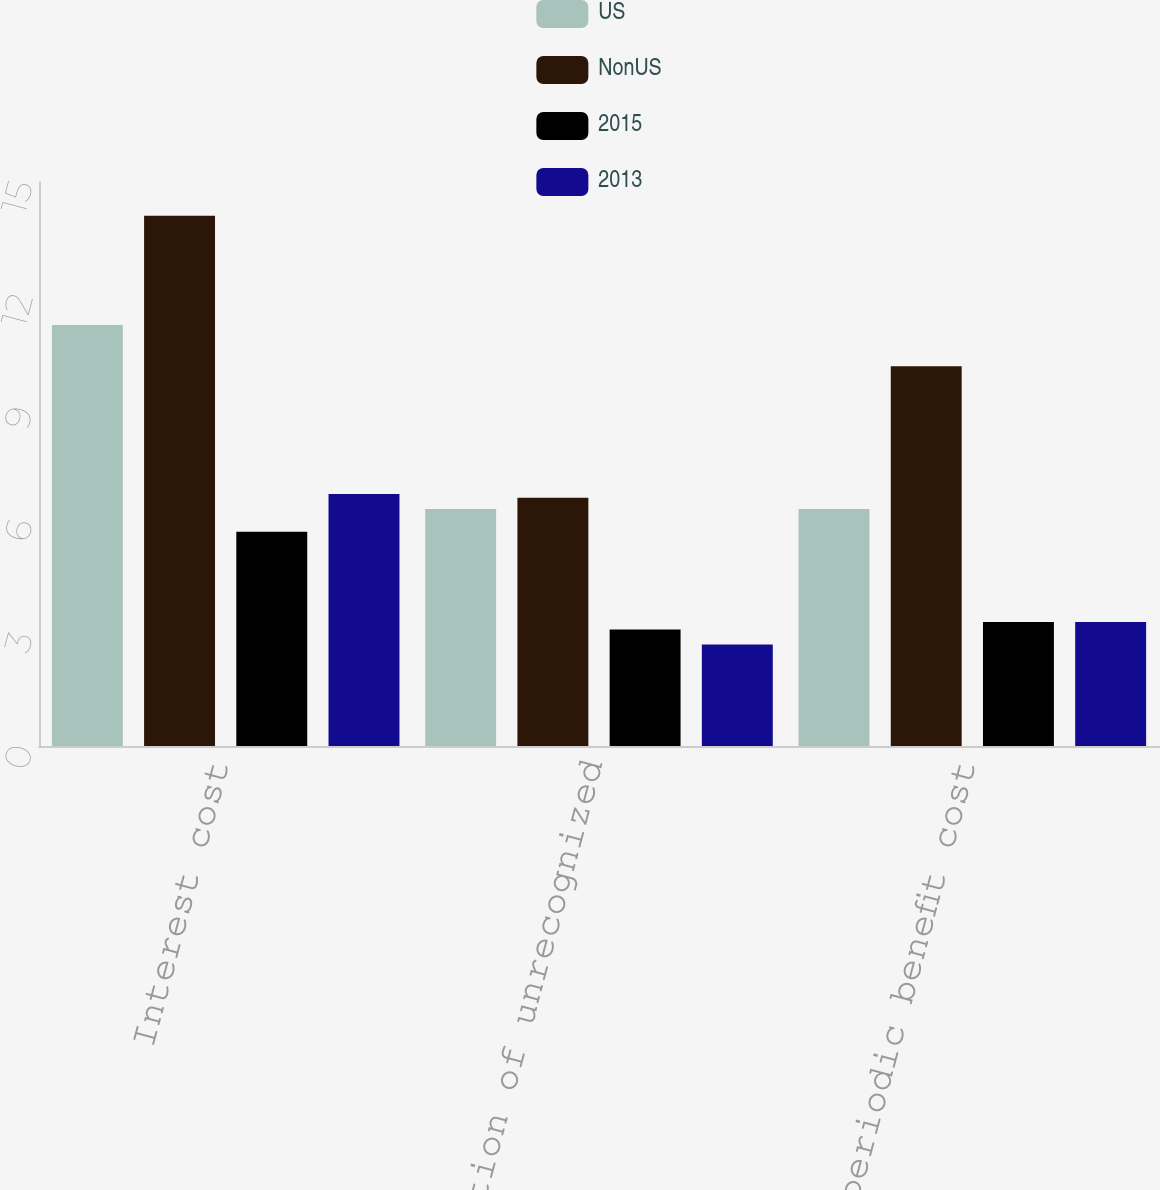Convert chart to OTSL. <chart><loc_0><loc_0><loc_500><loc_500><stacked_bar_chart><ecel><fcel>Interest cost<fcel>Amortization of unrecognized<fcel>Net periodic benefit cost<nl><fcel>US<fcel>11.2<fcel>6.3<fcel>6.3<nl><fcel>NonUS<fcel>14.1<fcel>6.6<fcel>10.1<nl><fcel>2015<fcel>5.7<fcel>3.1<fcel>3.3<nl><fcel>2013<fcel>6.7<fcel>2.7<fcel>3.3<nl></chart> 